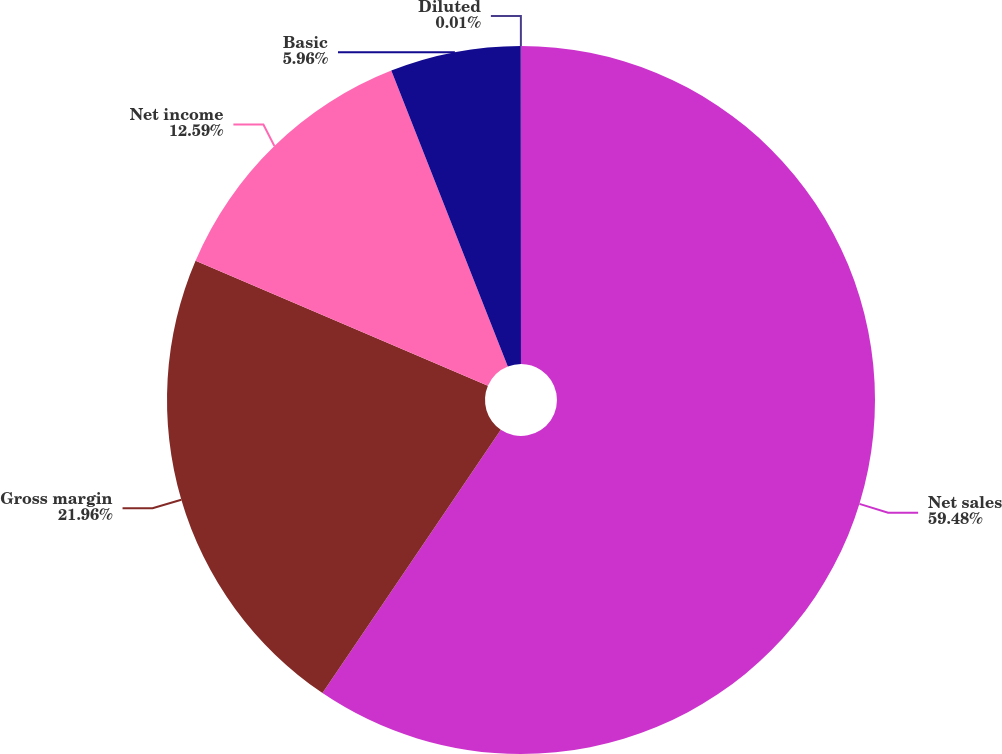Convert chart. <chart><loc_0><loc_0><loc_500><loc_500><pie_chart><fcel>Net sales<fcel>Gross margin<fcel>Net income<fcel>Basic<fcel>Diluted<nl><fcel>59.47%<fcel>21.96%<fcel>12.59%<fcel>5.96%<fcel>0.01%<nl></chart> 